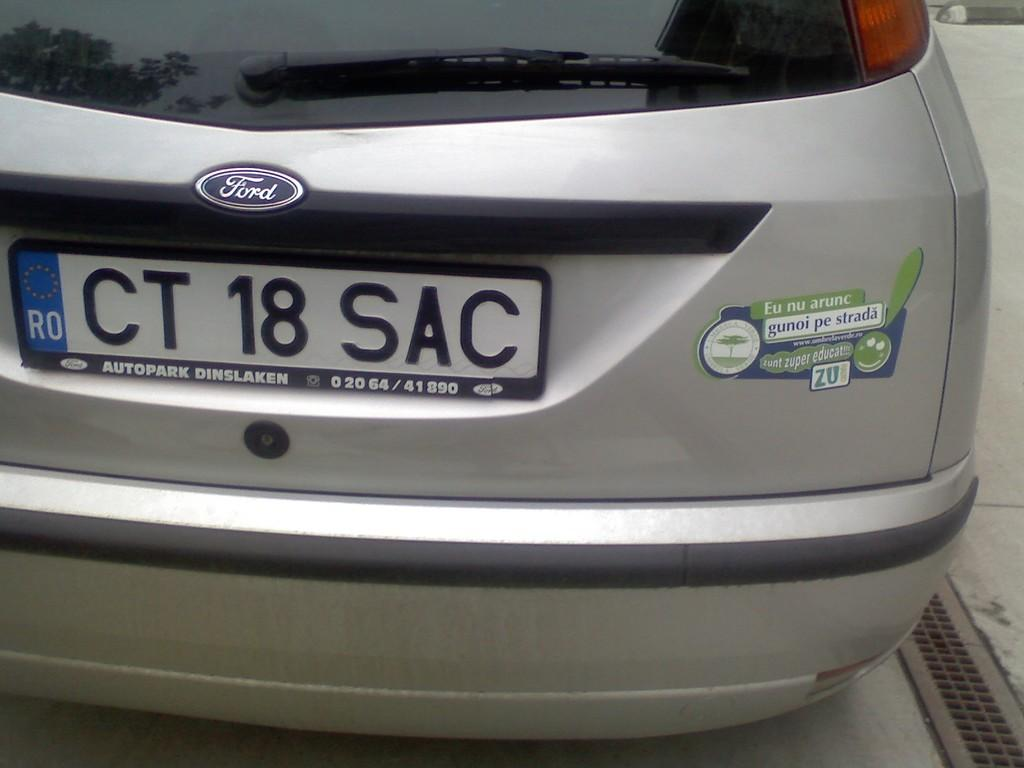Provide a one-sentence caption for the provided image. A ford car with license plate CT 18 SAC. 